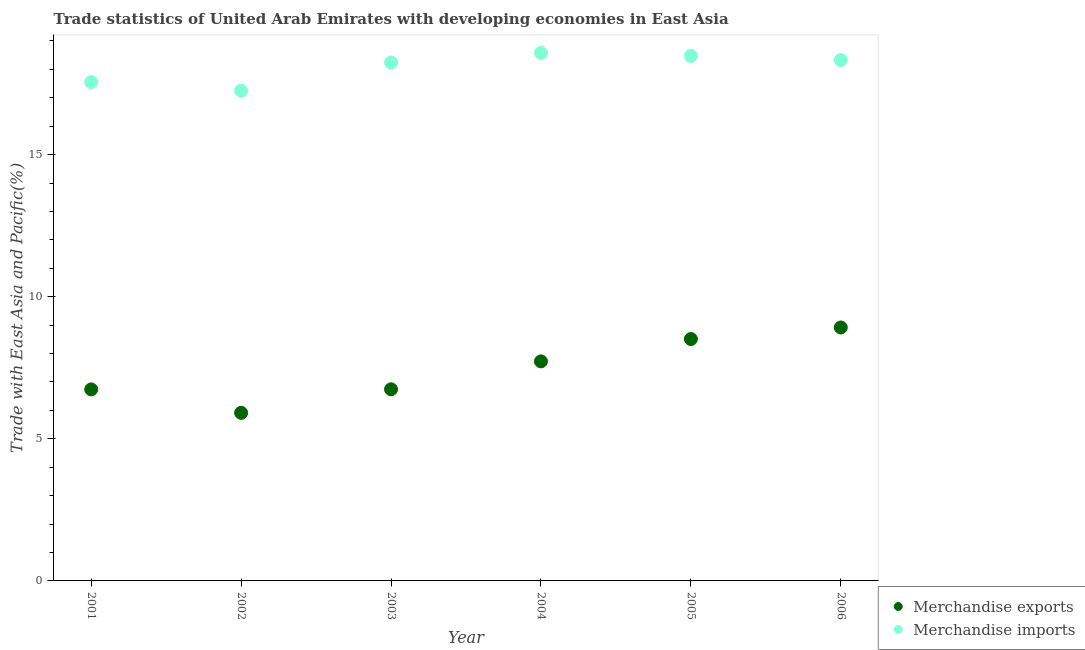Is the number of dotlines equal to the number of legend labels?
Provide a short and direct response. Yes. What is the merchandise imports in 2005?
Provide a succinct answer. 18.47. Across all years, what is the maximum merchandise imports?
Offer a very short reply. 18.58. Across all years, what is the minimum merchandise imports?
Provide a succinct answer. 17.25. In which year was the merchandise exports minimum?
Give a very brief answer. 2002. What is the total merchandise exports in the graph?
Provide a short and direct response. 44.55. What is the difference between the merchandise imports in 2003 and that in 2004?
Give a very brief answer. -0.34. What is the difference between the merchandise exports in 2003 and the merchandise imports in 2006?
Give a very brief answer. -11.58. What is the average merchandise exports per year?
Offer a terse response. 7.42. In the year 2001, what is the difference between the merchandise imports and merchandise exports?
Give a very brief answer. 10.81. What is the ratio of the merchandise exports in 2003 to that in 2005?
Offer a terse response. 0.79. Is the merchandise imports in 2003 less than that in 2004?
Ensure brevity in your answer.  Yes. Is the difference between the merchandise exports in 2003 and 2004 greater than the difference between the merchandise imports in 2003 and 2004?
Provide a succinct answer. No. What is the difference between the highest and the second highest merchandise imports?
Give a very brief answer. 0.11. What is the difference between the highest and the lowest merchandise exports?
Your answer should be compact. 3. In how many years, is the merchandise imports greater than the average merchandise imports taken over all years?
Offer a very short reply. 4. Is the sum of the merchandise exports in 2004 and 2006 greater than the maximum merchandise imports across all years?
Provide a short and direct response. No. Does the merchandise exports monotonically increase over the years?
Your answer should be very brief. No. Is the merchandise exports strictly greater than the merchandise imports over the years?
Provide a short and direct response. No. How many years are there in the graph?
Provide a succinct answer. 6. Are the values on the major ticks of Y-axis written in scientific E-notation?
Ensure brevity in your answer.  No. Does the graph contain any zero values?
Your response must be concise. No. How many legend labels are there?
Provide a short and direct response. 2. How are the legend labels stacked?
Offer a very short reply. Vertical. What is the title of the graph?
Your answer should be compact. Trade statistics of United Arab Emirates with developing economies in East Asia. Does "Foreign liabilities" appear as one of the legend labels in the graph?
Give a very brief answer. No. What is the label or title of the Y-axis?
Your response must be concise. Trade with East Asia and Pacific(%). What is the Trade with East Asia and Pacific(%) of Merchandise exports in 2001?
Offer a very short reply. 6.74. What is the Trade with East Asia and Pacific(%) in Merchandise imports in 2001?
Provide a short and direct response. 17.55. What is the Trade with East Asia and Pacific(%) in Merchandise exports in 2002?
Your answer should be very brief. 5.91. What is the Trade with East Asia and Pacific(%) in Merchandise imports in 2002?
Keep it short and to the point. 17.25. What is the Trade with East Asia and Pacific(%) of Merchandise exports in 2003?
Provide a short and direct response. 6.74. What is the Trade with East Asia and Pacific(%) in Merchandise imports in 2003?
Keep it short and to the point. 18.24. What is the Trade with East Asia and Pacific(%) in Merchandise exports in 2004?
Keep it short and to the point. 7.72. What is the Trade with East Asia and Pacific(%) of Merchandise imports in 2004?
Offer a terse response. 18.58. What is the Trade with East Asia and Pacific(%) in Merchandise exports in 2005?
Make the answer very short. 8.51. What is the Trade with East Asia and Pacific(%) of Merchandise imports in 2005?
Ensure brevity in your answer.  18.47. What is the Trade with East Asia and Pacific(%) of Merchandise exports in 2006?
Offer a very short reply. 8.92. What is the Trade with East Asia and Pacific(%) in Merchandise imports in 2006?
Your answer should be compact. 18.33. Across all years, what is the maximum Trade with East Asia and Pacific(%) of Merchandise exports?
Ensure brevity in your answer.  8.92. Across all years, what is the maximum Trade with East Asia and Pacific(%) in Merchandise imports?
Offer a terse response. 18.58. Across all years, what is the minimum Trade with East Asia and Pacific(%) in Merchandise exports?
Provide a succinct answer. 5.91. Across all years, what is the minimum Trade with East Asia and Pacific(%) in Merchandise imports?
Your answer should be very brief. 17.25. What is the total Trade with East Asia and Pacific(%) in Merchandise exports in the graph?
Ensure brevity in your answer.  44.55. What is the total Trade with East Asia and Pacific(%) of Merchandise imports in the graph?
Give a very brief answer. 108.42. What is the difference between the Trade with East Asia and Pacific(%) in Merchandise exports in 2001 and that in 2002?
Your answer should be compact. 0.82. What is the difference between the Trade with East Asia and Pacific(%) of Merchandise imports in 2001 and that in 2002?
Provide a succinct answer. 0.3. What is the difference between the Trade with East Asia and Pacific(%) in Merchandise exports in 2001 and that in 2003?
Provide a short and direct response. -0. What is the difference between the Trade with East Asia and Pacific(%) in Merchandise imports in 2001 and that in 2003?
Keep it short and to the point. -0.69. What is the difference between the Trade with East Asia and Pacific(%) of Merchandise exports in 2001 and that in 2004?
Keep it short and to the point. -0.99. What is the difference between the Trade with East Asia and Pacific(%) of Merchandise imports in 2001 and that in 2004?
Your response must be concise. -1.03. What is the difference between the Trade with East Asia and Pacific(%) of Merchandise exports in 2001 and that in 2005?
Provide a short and direct response. -1.77. What is the difference between the Trade with East Asia and Pacific(%) of Merchandise imports in 2001 and that in 2005?
Your answer should be very brief. -0.92. What is the difference between the Trade with East Asia and Pacific(%) in Merchandise exports in 2001 and that in 2006?
Offer a very short reply. -2.18. What is the difference between the Trade with East Asia and Pacific(%) in Merchandise imports in 2001 and that in 2006?
Offer a very short reply. -0.78. What is the difference between the Trade with East Asia and Pacific(%) in Merchandise exports in 2002 and that in 2003?
Provide a succinct answer. -0.83. What is the difference between the Trade with East Asia and Pacific(%) in Merchandise imports in 2002 and that in 2003?
Your answer should be very brief. -0.99. What is the difference between the Trade with East Asia and Pacific(%) in Merchandise exports in 2002 and that in 2004?
Offer a terse response. -1.81. What is the difference between the Trade with East Asia and Pacific(%) of Merchandise imports in 2002 and that in 2004?
Make the answer very short. -1.33. What is the difference between the Trade with East Asia and Pacific(%) of Merchandise exports in 2002 and that in 2005?
Make the answer very short. -2.6. What is the difference between the Trade with East Asia and Pacific(%) of Merchandise imports in 2002 and that in 2005?
Provide a succinct answer. -1.22. What is the difference between the Trade with East Asia and Pacific(%) of Merchandise exports in 2002 and that in 2006?
Ensure brevity in your answer.  -3. What is the difference between the Trade with East Asia and Pacific(%) of Merchandise imports in 2002 and that in 2006?
Your answer should be compact. -1.08. What is the difference between the Trade with East Asia and Pacific(%) of Merchandise exports in 2003 and that in 2004?
Provide a succinct answer. -0.98. What is the difference between the Trade with East Asia and Pacific(%) of Merchandise imports in 2003 and that in 2004?
Ensure brevity in your answer.  -0.34. What is the difference between the Trade with East Asia and Pacific(%) in Merchandise exports in 2003 and that in 2005?
Offer a terse response. -1.77. What is the difference between the Trade with East Asia and Pacific(%) in Merchandise imports in 2003 and that in 2005?
Give a very brief answer. -0.23. What is the difference between the Trade with East Asia and Pacific(%) of Merchandise exports in 2003 and that in 2006?
Ensure brevity in your answer.  -2.17. What is the difference between the Trade with East Asia and Pacific(%) of Merchandise imports in 2003 and that in 2006?
Offer a terse response. -0.09. What is the difference between the Trade with East Asia and Pacific(%) of Merchandise exports in 2004 and that in 2005?
Your answer should be compact. -0.79. What is the difference between the Trade with East Asia and Pacific(%) of Merchandise imports in 2004 and that in 2005?
Offer a terse response. 0.11. What is the difference between the Trade with East Asia and Pacific(%) of Merchandise exports in 2004 and that in 2006?
Your answer should be compact. -1.19. What is the difference between the Trade with East Asia and Pacific(%) in Merchandise imports in 2004 and that in 2006?
Provide a succinct answer. 0.25. What is the difference between the Trade with East Asia and Pacific(%) of Merchandise exports in 2005 and that in 2006?
Give a very brief answer. -0.41. What is the difference between the Trade with East Asia and Pacific(%) of Merchandise imports in 2005 and that in 2006?
Make the answer very short. 0.15. What is the difference between the Trade with East Asia and Pacific(%) of Merchandise exports in 2001 and the Trade with East Asia and Pacific(%) of Merchandise imports in 2002?
Provide a short and direct response. -10.51. What is the difference between the Trade with East Asia and Pacific(%) in Merchandise exports in 2001 and the Trade with East Asia and Pacific(%) in Merchandise imports in 2003?
Ensure brevity in your answer.  -11.5. What is the difference between the Trade with East Asia and Pacific(%) in Merchandise exports in 2001 and the Trade with East Asia and Pacific(%) in Merchandise imports in 2004?
Provide a short and direct response. -11.84. What is the difference between the Trade with East Asia and Pacific(%) in Merchandise exports in 2001 and the Trade with East Asia and Pacific(%) in Merchandise imports in 2005?
Offer a very short reply. -11.73. What is the difference between the Trade with East Asia and Pacific(%) of Merchandise exports in 2001 and the Trade with East Asia and Pacific(%) of Merchandise imports in 2006?
Your response must be concise. -11.59. What is the difference between the Trade with East Asia and Pacific(%) of Merchandise exports in 2002 and the Trade with East Asia and Pacific(%) of Merchandise imports in 2003?
Ensure brevity in your answer.  -12.32. What is the difference between the Trade with East Asia and Pacific(%) of Merchandise exports in 2002 and the Trade with East Asia and Pacific(%) of Merchandise imports in 2004?
Your answer should be very brief. -12.66. What is the difference between the Trade with East Asia and Pacific(%) in Merchandise exports in 2002 and the Trade with East Asia and Pacific(%) in Merchandise imports in 2005?
Your answer should be very brief. -12.56. What is the difference between the Trade with East Asia and Pacific(%) of Merchandise exports in 2002 and the Trade with East Asia and Pacific(%) of Merchandise imports in 2006?
Your answer should be compact. -12.41. What is the difference between the Trade with East Asia and Pacific(%) in Merchandise exports in 2003 and the Trade with East Asia and Pacific(%) in Merchandise imports in 2004?
Your response must be concise. -11.84. What is the difference between the Trade with East Asia and Pacific(%) in Merchandise exports in 2003 and the Trade with East Asia and Pacific(%) in Merchandise imports in 2005?
Ensure brevity in your answer.  -11.73. What is the difference between the Trade with East Asia and Pacific(%) in Merchandise exports in 2003 and the Trade with East Asia and Pacific(%) in Merchandise imports in 2006?
Provide a short and direct response. -11.58. What is the difference between the Trade with East Asia and Pacific(%) of Merchandise exports in 2004 and the Trade with East Asia and Pacific(%) of Merchandise imports in 2005?
Offer a terse response. -10.75. What is the difference between the Trade with East Asia and Pacific(%) in Merchandise exports in 2004 and the Trade with East Asia and Pacific(%) in Merchandise imports in 2006?
Ensure brevity in your answer.  -10.6. What is the difference between the Trade with East Asia and Pacific(%) in Merchandise exports in 2005 and the Trade with East Asia and Pacific(%) in Merchandise imports in 2006?
Offer a terse response. -9.82. What is the average Trade with East Asia and Pacific(%) in Merchandise exports per year?
Make the answer very short. 7.42. What is the average Trade with East Asia and Pacific(%) in Merchandise imports per year?
Make the answer very short. 18.07. In the year 2001, what is the difference between the Trade with East Asia and Pacific(%) of Merchandise exports and Trade with East Asia and Pacific(%) of Merchandise imports?
Offer a terse response. -10.81. In the year 2002, what is the difference between the Trade with East Asia and Pacific(%) of Merchandise exports and Trade with East Asia and Pacific(%) of Merchandise imports?
Offer a terse response. -11.34. In the year 2003, what is the difference between the Trade with East Asia and Pacific(%) of Merchandise exports and Trade with East Asia and Pacific(%) of Merchandise imports?
Offer a very short reply. -11.5. In the year 2004, what is the difference between the Trade with East Asia and Pacific(%) in Merchandise exports and Trade with East Asia and Pacific(%) in Merchandise imports?
Give a very brief answer. -10.85. In the year 2005, what is the difference between the Trade with East Asia and Pacific(%) in Merchandise exports and Trade with East Asia and Pacific(%) in Merchandise imports?
Offer a terse response. -9.96. In the year 2006, what is the difference between the Trade with East Asia and Pacific(%) of Merchandise exports and Trade with East Asia and Pacific(%) of Merchandise imports?
Make the answer very short. -9.41. What is the ratio of the Trade with East Asia and Pacific(%) of Merchandise exports in 2001 to that in 2002?
Offer a very short reply. 1.14. What is the ratio of the Trade with East Asia and Pacific(%) of Merchandise imports in 2001 to that in 2002?
Keep it short and to the point. 1.02. What is the ratio of the Trade with East Asia and Pacific(%) of Merchandise exports in 2001 to that in 2003?
Your answer should be compact. 1. What is the ratio of the Trade with East Asia and Pacific(%) of Merchandise imports in 2001 to that in 2003?
Give a very brief answer. 0.96. What is the ratio of the Trade with East Asia and Pacific(%) of Merchandise exports in 2001 to that in 2004?
Ensure brevity in your answer.  0.87. What is the ratio of the Trade with East Asia and Pacific(%) of Merchandise imports in 2001 to that in 2004?
Your answer should be very brief. 0.94. What is the ratio of the Trade with East Asia and Pacific(%) in Merchandise exports in 2001 to that in 2005?
Give a very brief answer. 0.79. What is the ratio of the Trade with East Asia and Pacific(%) of Merchandise imports in 2001 to that in 2005?
Offer a terse response. 0.95. What is the ratio of the Trade with East Asia and Pacific(%) in Merchandise exports in 2001 to that in 2006?
Your response must be concise. 0.76. What is the ratio of the Trade with East Asia and Pacific(%) in Merchandise imports in 2001 to that in 2006?
Your response must be concise. 0.96. What is the ratio of the Trade with East Asia and Pacific(%) in Merchandise exports in 2002 to that in 2003?
Your answer should be compact. 0.88. What is the ratio of the Trade with East Asia and Pacific(%) in Merchandise imports in 2002 to that in 2003?
Make the answer very short. 0.95. What is the ratio of the Trade with East Asia and Pacific(%) in Merchandise exports in 2002 to that in 2004?
Your answer should be very brief. 0.77. What is the ratio of the Trade with East Asia and Pacific(%) of Merchandise imports in 2002 to that in 2004?
Your answer should be compact. 0.93. What is the ratio of the Trade with East Asia and Pacific(%) of Merchandise exports in 2002 to that in 2005?
Give a very brief answer. 0.69. What is the ratio of the Trade with East Asia and Pacific(%) of Merchandise imports in 2002 to that in 2005?
Provide a succinct answer. 0.93. What is the ratio of the Trade with East Asia and Pacific(%) of Merchandise exports in 2002 to that in 2006?
Ensure brevity in your answer.  0.66. What is the ratio of the Trade with East Asia and Pacific(%) of Merchandise imports in 2002 to that in 2006?
Make the answer very short. 0.94. What is the ratio of the Trade with East Asia and Pacific(%) of Merchandise exports in 2003 to that in 2004?
Your answer should be very brief. 0.87. What is the ratio of the Trade with East Asia and Pacific(%) of Merchandise imports in 2003 to that in 2004?
Make the answer very short. 0.98. What is the ratio of the Trade with East Asia and Pacific(%) in Merchandise exports in 2003 to that in 2005?
Provide a short and direct response. 0.79. What is the ratio of the Trade with East Asia and Pacific(%) in Merchandise imports in 2003 to that in 2005?
Provide a short and direct response. 0.99. What is the ratio of the Trade with East Asia and Pacific(%) of Merchandise exports in 2003 to that in 2006?
Give a very brief answer. 0.76. What is the ratio of the Trade with East Asia and Pacific(%) of Merchandise imports in 2003 to that in 2006?
Your response must be concise. 1. What is the ratio of the Trade with East Asia and Pacific(%) in Merchandise exports in 2004 to that in 2005?
Your answer should be very brief. 0.91. What is the ratio of the Trade with East Asia and Pacific(%) in Merchandise imports in 2004 to that in 2005?
Offer a very short reply. 1.01. What is the ratio of the Trade with East Asia and Pacific(%) of Merchandise exports in 2004 to that in 2006?
Ensure brevity in your answer.  0.87. What is the ratio of the Trade with East Asia and Pacific(%) in Merchandise imports in 2004 to that in 2006?
Your response must be concise. 1.01. What is the ratio of the Trade with East Asia and Pacific(%) of Merchandise exports in 2005 to that in 2006?
Your answer should be compact. 0.95. What is the difference between the highest and the second highest Trade with East Asia and Pacific(%) in Merchandise exports?
Provide a short and direct response. 0.41. What is the difference between the highest and the second highest Trade with East Asia and Pacific(%) of Merchandise imports?
Your answer should be very brief. 0.11. What is the difference between the highest and the lowest Trade with East Asia and Pacific(%) in Merchandise exports?
Provide a succinct answer. 3. What is the difference between the highest and the lowest Trade with East Asia and Pacific(%) in Merchandise imports?
Your response must be concise. 1.33. 